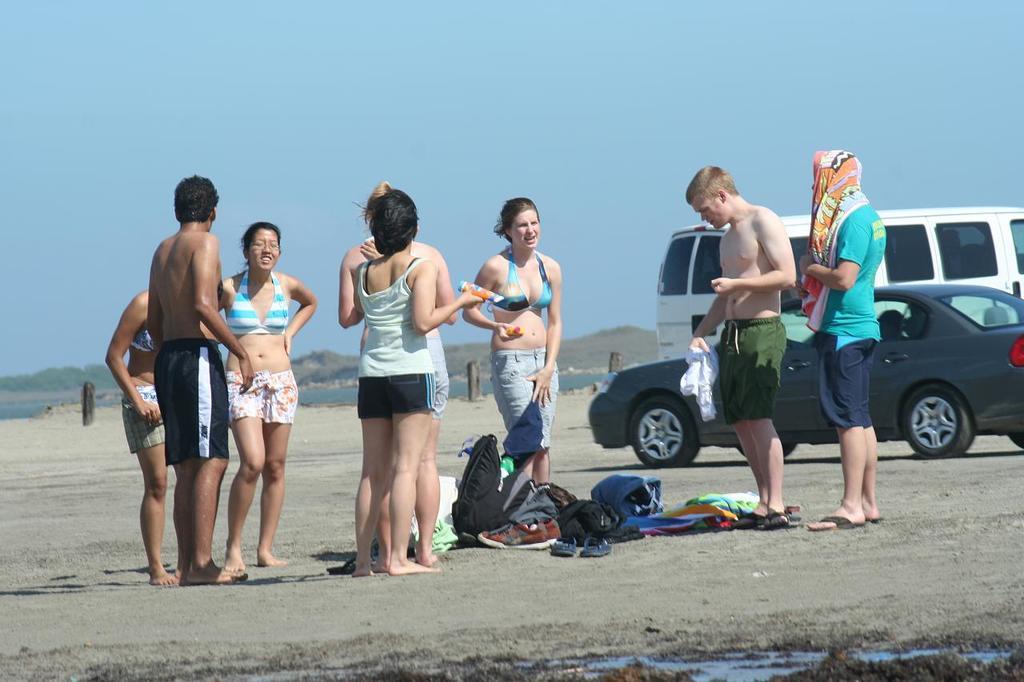Could you give a brief overview of what you see in this image? In this image we can see a few people standing on the land. We can also see the bags, clothes and footwear on the ground. In the background we can see the vehicles, wooden poles, water, trees. We can also see the sky. 